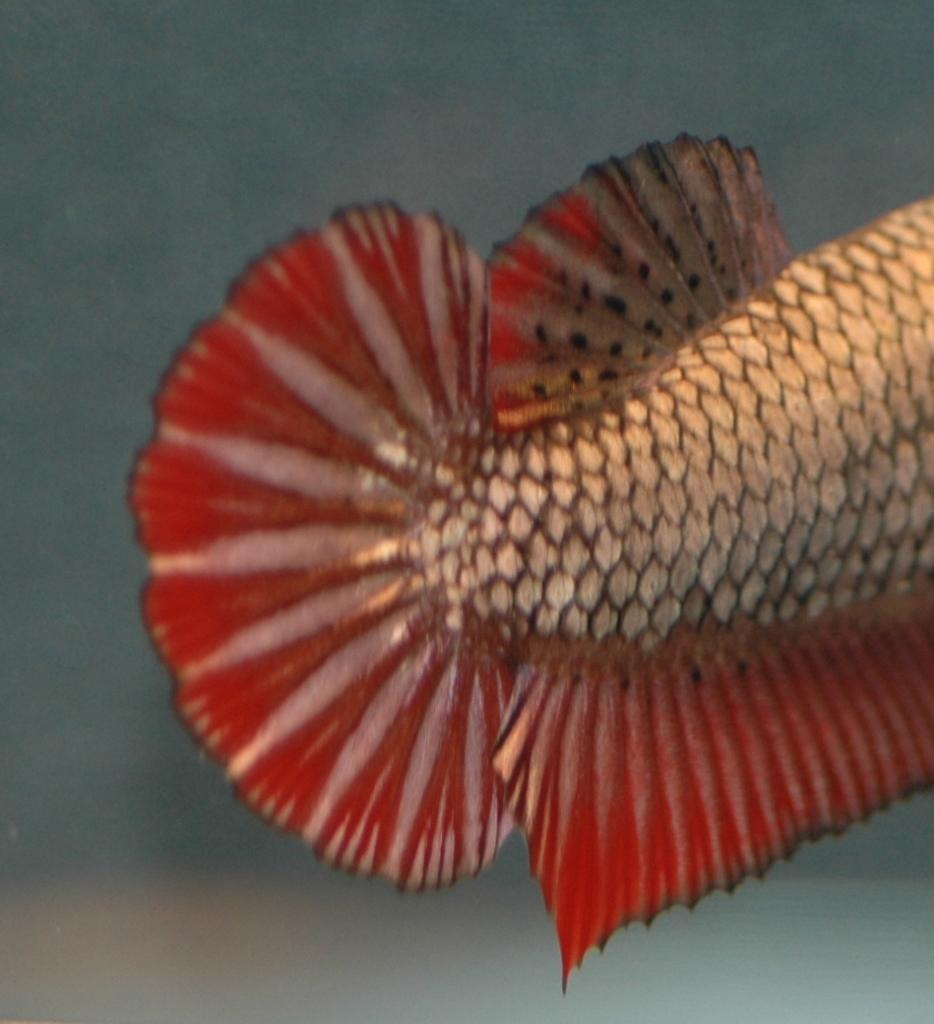What type of animal is depicted in the image? The image contains the back part of a fish. Can you describe the specific features of the fish in the image? Unfortunately, only the back part of the fish is visible, so it is difficult to describe specific features. What might be the purpose of this image? It is unclear what the purpose of the image is without additional context. How does the fish contribute to the local industry in the image? There is no indication of an industry or any human activity in the image, so it is not possible to determine how the fish might contribute to a local industry. 